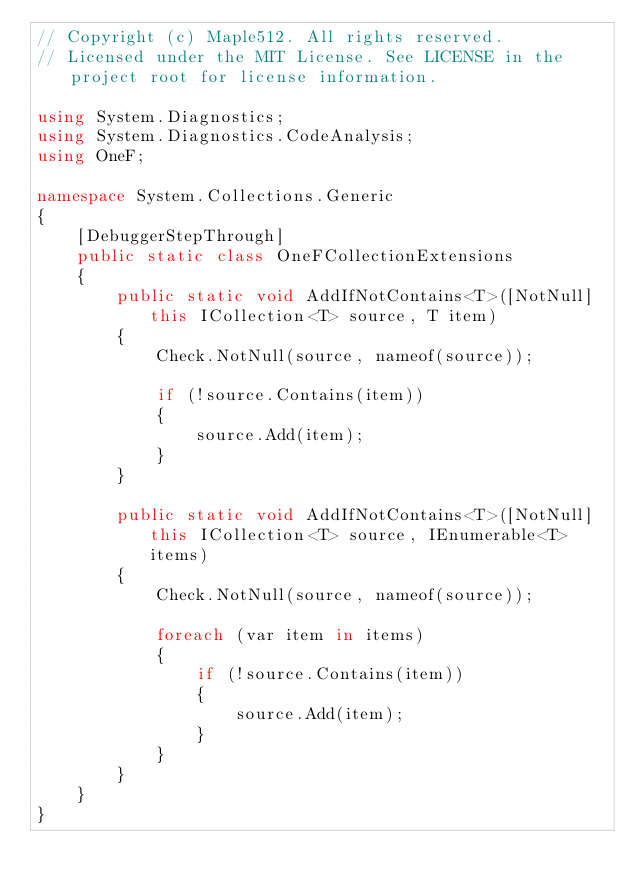Convert code to text. <code><loc_0><loc_0><loc_500><loc_500><_C#_>// Copyright (c) Maple512. All rights reserved.
// Licensed under the MIT License. See LICENSE in the project root for license information.

using System.Diagnostics;
using System.Diagnostics.CodeAnalysis;
using OneF;

namespace System.Collections.Generic
{
    [DebuggerStepThrough]
    public static class OneFCollectionExtensions
    {
        public static void AddIfNotContains<T>([NotNull] this ICollection<T> source, T item)
        {
            Check.NotNull(source, nameof(source));

            if (!source.Contains(item))
            {
                source.Add(item);
            }
        }

        public static void AddIfNotContains<T>([NotNull] this ICollection<T> source, IEnumerable<T> items)
        {
            Check.NotNull(source, nameof(source));

            foreach (var item in items)
            {
                if (!source.Contains(item))
                {
                    source.Add(item);
                }
            }
        }
    }
}
</code> 